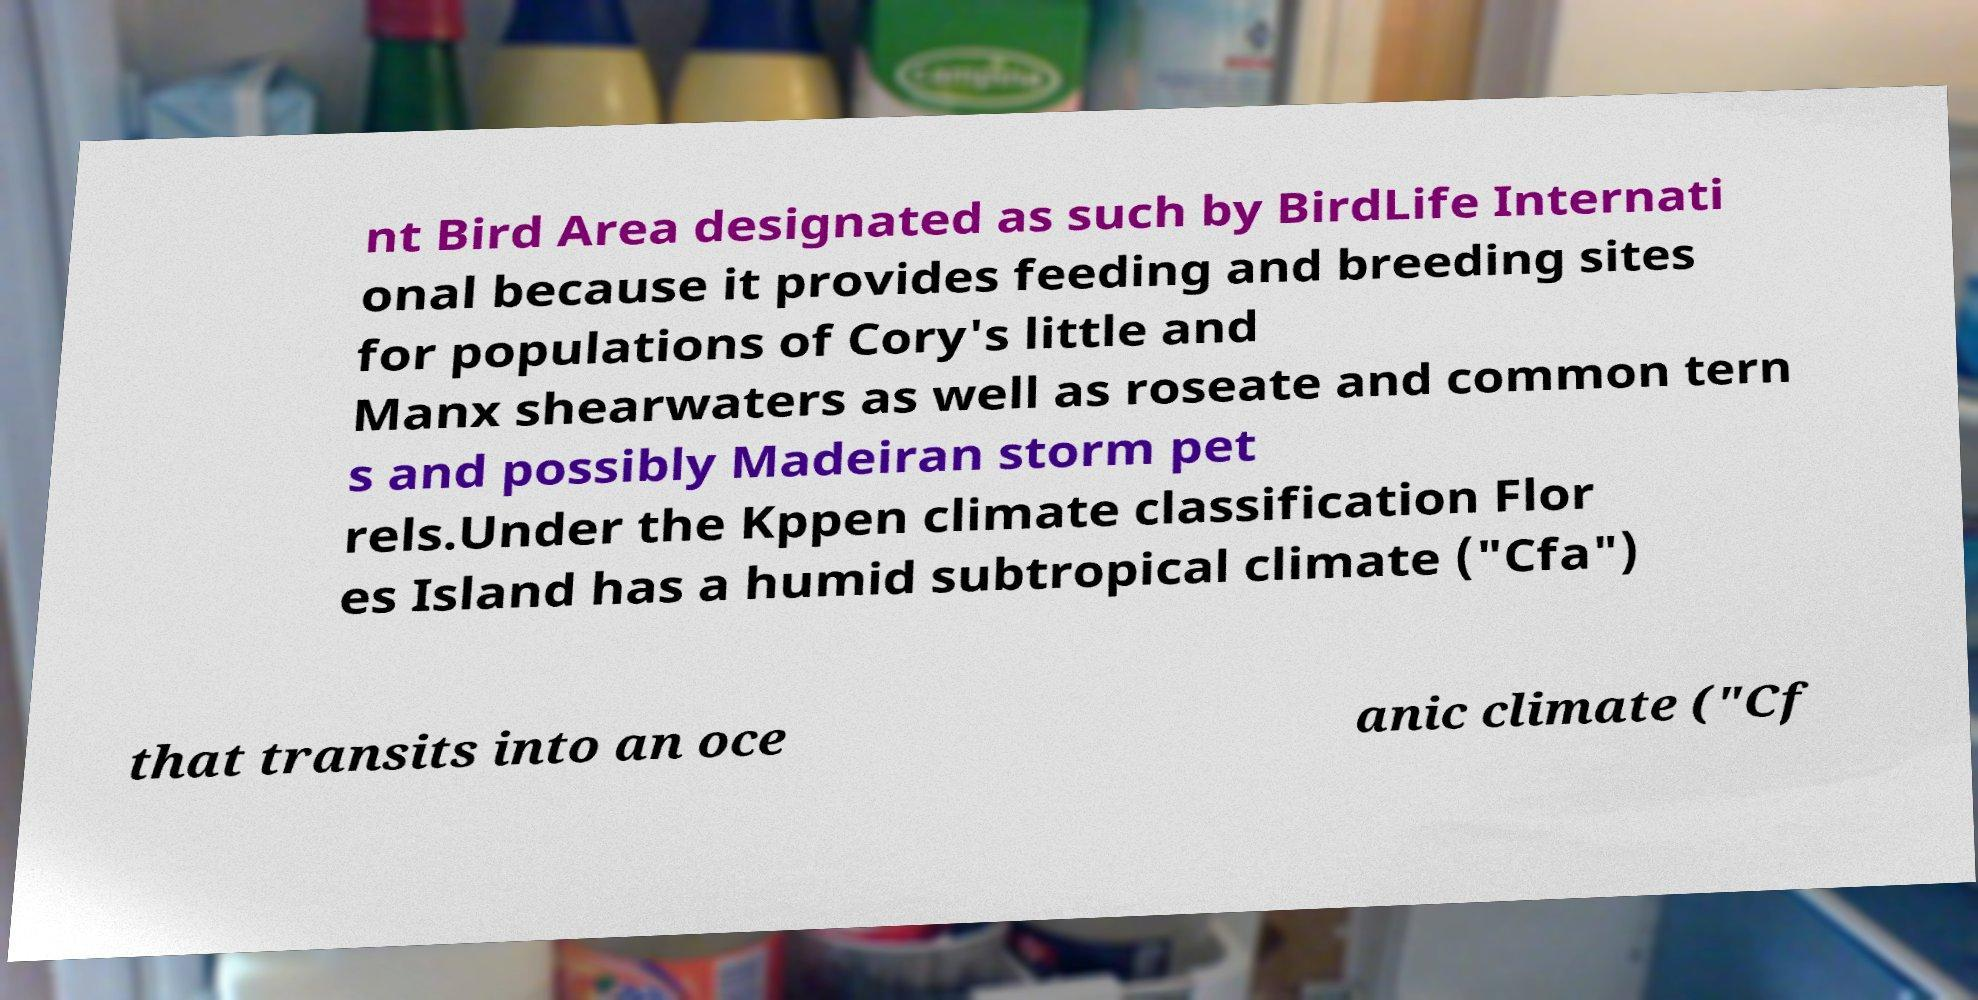Please read and relay the text visible in this image. What does it say? nt Bird Area designated as such by BirdLife Internati onal because it provides feeding and breeding sites for populations of Cory's little and Manx shearwaters as well as roseate and common tern s and possibly Madeiran storm pet rels.Under the Kppen climate classification Flor es Island has a humid subtropical climate ("Cfa") that transits into an oce anic climate ("Cf 